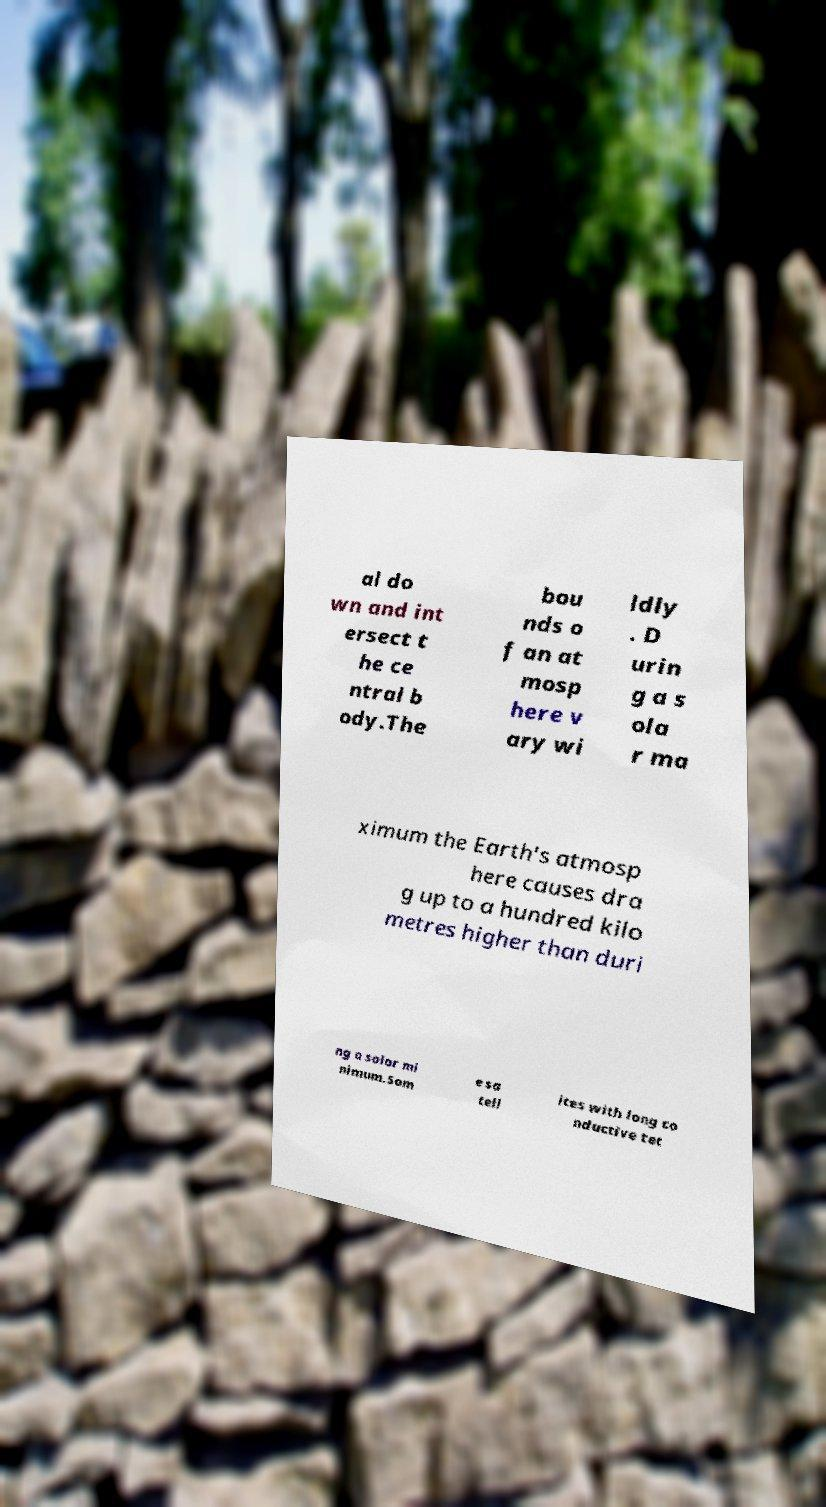Please read and relay the text visible in this image. What does it say? al do wn and int ersect t he ce ntral b ody.The bou nds o f an at mosp here v ary wi ldly . D urin g a s ola r ma ximum the Earth's atmosp here causes dra g up to a hundred kilo metres higher than duri ng a solar mi nimum.Som e sa tell ites with long co nductive tet 